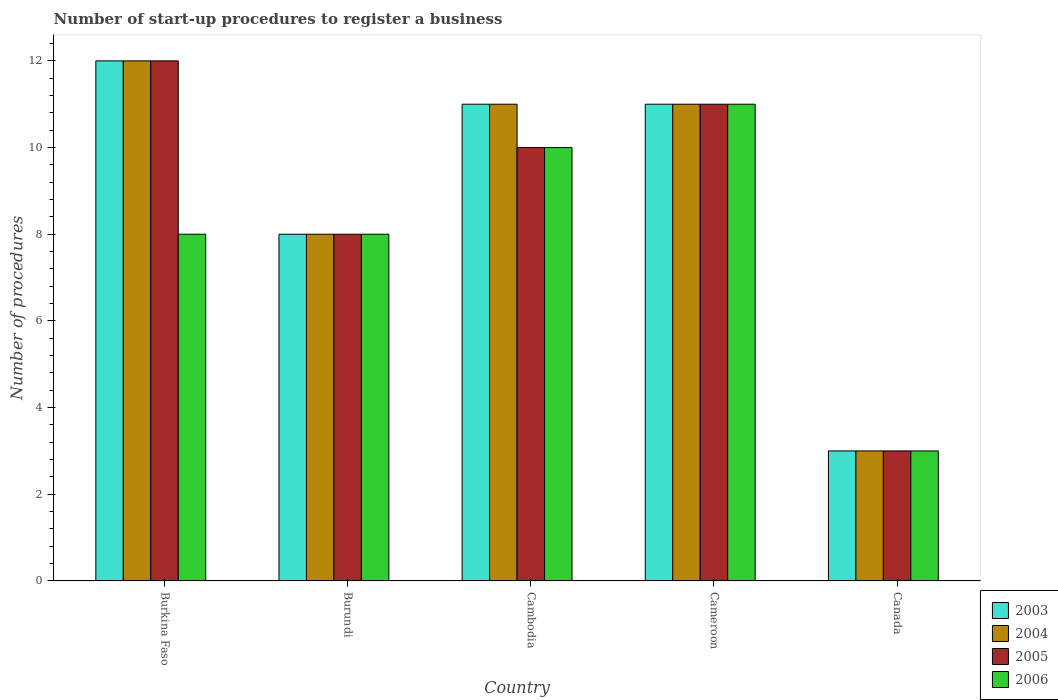How many different coloured bars are there?
Make the answer very short. 4. Are the number of bars per tick equal to the number of legend labels?
Ensure brevity in your answer.  Yes. How many bars are there on the 2nd tick from the left?
Your answer should be compact. 4. How many bars are there on the 4th tick from the right?
Your response must be concise. 4. What is the label of the 5th group of bars from the left?
Your response must be concise. Canada. In how many cases, is the number of bars for a given country not equal to the number of legend labels?
Make the answer very short. 0. What is the number of procedures required to register a business in 2003 in Burkina Faso?
Your answer should be very brief. 12. In which country was the number of procedures required to register a business in 2005 maximum?
Your answer should be very brief. Burkina Faso. What is the total number of procedures required to register a business in 2003 in the graph?
Keep it short and to the point. 45. What is the difference between the number of procedures required to register a business in 2006 in Burundi and that in Canada?
Offer a terse response. 5. What is the difference between the number of procedures required to register a business in 2003 in Burundi and the number of procedures required to register a business in 2006 in Canada?
Provide a succinct answer. 5. What is the average number of procedures required to register a business in 2005 per country?
Ensure brevity in your answer.  8.8. In how many countries, is the number of procedures required to register a business in 2003 greater than 9.6?
Keep it short and to the point. 3. What is the ratio of the number of procedures required to register a business in 2005 in Burkina Faso to that in Cambodia?
Provide a short and direct response. 1.2. In how many countries, is the number of procedures required to register a business in 2006 greater than the average number of procedures required to register a business in 2006 taken over all countries?
Ensure brevity in your answer.  2. Is the sum of the number of procedures required to register a business in 2003 in Cambodia and Cameroon greater than the maximum number of procedures required to register a business in 2006 across all countries?
Offer a terse response. Yes. What does the 1st bar from the left in Burkina Faso represents?
Keep it short and to the point. 2003. What does the 4th bar from the right in Burundi represents?
Offer a terse response. 2003. Is it the case that in every country, the sum of the number of procedures required to register a business in 2006 and number of procedures required to register a business in 2005 is greater than the number of procedures required to register a business in 2004?
Your answer should be very brief. Yes. Are all the bars in the graph horizontal?
Provide a succinct answer. No. Where does the legend appear in the graph?
Your answer should be compact. Bottom right. What is the title of the graph?
Give a very brief answer. Number of start-up procedures to register a business. What is the label or title of the Y-axis?
Your response must be concise. Number of procedures. What is the Number of procedures of 2005 in Burkina Faso?
Give a very brief answer. 12. What is the Number of procedures in 2006 in Burkina Faso?
Give a very brief answer. 8. What is the Number of procedures of 2005 in Burundi?
Offer a terse response. 8. What is the Number of procedures in 2006 in Burundi?
Provide a short and direct response. 8. What is the Number of procedures in 2003 in Cambodia?
Ensure brevity in your answer.  11. What is the Number of procedures of 2004 in Cambodia?
Offer a terse response. 11. What is the Number of procedures of 2005 in Cambodia?
Provide a short and direct response. 10. What is the Number of procedures in 2006 in Cambodia?
Provide a succinct answer. 10. What is the Number of procedures of 2003 in Cameroon?
Your response must be concise. 11. What is the Number of procedures of 2005 in Cameroon?
Ensure brevity in your answer.  11. What is the Number of procedures in 2003 in Canada?
Offer a terse response. 3. What is the Number of procedures of 2006 in Canada?
Offer a terse response. 3. Across all countries, what is the minimum Number of procedures of 2004?
Provide a short and direct response. 3. Across all countries, what is the minimum Number of procedures in 2005?
Offer a terse response. 3. What is the total Number of procedures of 2003 in the graph?
Keep it short and to the point. 45. What is the total Number of procedures in 2004 in the graph?
Give a very brief answer. 45. What is the total Number of procedures of 2005 in the graph?
Give a very brief answer. 44. What is the difference between the Number of procedures of 2003 in Burkina Faso and that in Burundi?
Ensure brevity in your answer.  4. What is the difference between the Number of procedures of 2004 in Burkina Faso and that in Burundi?
Provide a short and direct response. 4. What is the difference between the Number of procedures of 2005 in Burkina Faso and that in Burundi?
Your answer should be very brief. 4. What is the difference between the Number of procedures in 2006 in Burkina Faso and that in Burundi?
Make the answer very short. 0. What is the difference between the Number of procedures of 2003 in Burkina Faso and that in Cambodia?
Offer a very short reply. 1. What is the difference between the Number of procedures in 2006 in Burkina Faso and that in Cambodia?
Your response must be concise. -2. What is the difference between the Number of procedures in 2004 in Burkina Faso and that in Cameroon?
Make the answer very short. 1. What is the difference between the Number of procedures of 2005 in Burkina Faso and that in Cameroon?
Provide a succinct answer. 1. What is the difference between the Number of procedures of 2004 in Burkina Faso and that in Canada?
Offer a terse response. 9. What is the difference between the Number of procedures of 2005 in Burkina Faso and that in Canada?
Offer a terse response. 9. What is the difference between the Number of procedures of 2006 in Burkina Faso and that in Canada?
Provide a succinct answer. 5. What is the difference between the Number of procedures of 2005 in Burundi and that in Cambodia?
Your response must be concise. -2. What is the difference between the Number of procedures in 2003 in Burundi and that in Cameroon?
Offer a terse response. -3. What is the difference between the Number of procedures in 2004 in Burundi and that in Cameroon?
Make the answer very short. -3. What is the difference between the Number of procedures of 2003 in Burundi and that in Canada?
Your response must be concise. 5. What is the difference between the Number of procedures of 2005 in Burundi and that in Canada?
Provide a short and direct response. 5. What is the difference between the Number of procedures of 2005 in Cambodia and that in Cameroon?
Provide a succinct answer. -1. What is the difference between the Number of procedures of 2005 in Cambodia and that in Canada?
Your answer should be compact. 7. What is the difference between the Number of procedures in 2006 in Cambodia and that in Canada?
Your response must be concise. 7. What is the difference between the Number of procedures in 2003 in Cameroon and that in Canada?
Offer a very short reply. 8. What is the difference between the Number of procedures in 2004 in Cameroon and that in Canada?
Provide a short and direct response. 8. What is the difference between the Number of procedures in 2005 in Cameroon and that in Canada?
Your answer should be compact. 8. What is the difference between the Number of procedures of 2003 in Burkina Faso and the Number of procedures of 2004 in Burundi?
Your answer should be compact. 4. What is the difference between the Number of procedures of 2004 in Burkina Faso and the Number of procedures of 2006 in Burundi?
Keep it short and to the point. 4. What is the difference between the Number of procedures of 2004 in Burkina Faso and the Number of procedures of 2006 in Cambodia?
Offer a terse response. 2. What is the difference between the Number of procedures of 2003 in Burkina Faso and the Number of procedures of 2005 in Cameroon?
Your answer should be compact. 1. What is the difference between the Number of procedures in 2004 in Burkina Faso and the Number of procedures in 2005 in Cameroon?
Keep it short and to the point. 1. What is the difference between the Number of procedures of 2003 in Burkina Faso and the Number of procedures of 2005 in Canada?
Make the answer very short. 9. What is the difference between the Number of procedures of 2004 in Burkina Faso and the Number of procedures of 2005 in Canada?
Give a very brief answer. 9. What is the difference between the Number of procedures of 2004 in Burkina Faso and the Number of procedures of 2006 in Canada?
Offer a terse response. 9. What is the difference between the Number of procedures of 2003 in Burundi and the Number of procedures of 2004 in Cambodia?
Provide a succinct answer. -3. What is the difference between the Number of procedures of 2003 in Burundi and the Number of procedures of 2006 in Cambodia?
Give a very brief answer. -2. What is the difference between the Number of procedures in 2004 in Burundi and the Number of procedures in 2005 in Canada?
Your answer should be compact. 5. What is the difference between the Number of procedures of 2004 in Burundi and the Number of procedures of 2006 in Canada?
Give a very brief answer. 5. What is the difference between the Number of procedures in 2003 in Cambodia and the Number of procedures in 2004 in Cameroon?
Your answer should be very brief. 0. What is the difference between the Number of procedures of 2003 in Cambodia and the Number of procedures of 2005 in Cameroon?
Provide a succinct answer. 0. What is the difference between the Number of procedures of 2003 in Cambodia and the Number of procedures of 2006 in Cameroon?
Your answer should be very brief. 0. What is the difference between the Number of procedures in 2003 in Cambodia and the Number of procedures in 2005 in Canada?
Offer a terse response. 8. What is the difference between the Number of procedures in 2003 in Cambodia and the Number of procedures in 2006 in Canada?
Provide a short and direct response. 8. What is the difference between the Number of procedures in 2003 in Cameroon and the Number of procedures in 2004 in Canada?
Your answer should be compact. 8. What is the difference between the Number of procedures of 2003 in Cameroon and the Number of procedures of 2005 in Canada?
Make the answer very short. 8. What is the difference between the Number of procedures of 2003 in Cameroon and the Number of procedures of 2006 in Canada?
Give a very brief answer. 8. What is the difference between the Number of procedures in 2004 in Cameroon and the Number of procedures in 2005 in Canada?
Offer a very short reply. 8. What is the average Number of procedures of 2004 per country?
Your response must be concise. 9. What is the difference between the Number of procedures in 2003 and Number of procedures in 2005 in Burkina Faso?
Your response must be concise. 0. What is the difference between the Number of procedures of 2003 and Number of procedures of 2006 in Burkina Faso?
Your answer should be very brief. 4. What is the difference between the Number of procedures of 2004 and Number of procedures of 2005 in Burkina Faso?
Offer a very short reply. 0. What is the difference between the Number of procedures in 2003 and Number of procedures in 2004 in Burundi?
Provide a short and direct response. 0. What is the difference between the Number of procedures of 2003 and Number of procedures of 2005 in Burundi?
Ensure brevity in your answer.  0. What is the difference between the Number of procedures in 2003 and Number of procedures in 2006 in Burundi?
Give a very brief answer. 0. What is the difference between the Number of procedures in 2004 and Number of procedures in 2005 in Burundi?
Give a very brief answer. 0. What is the difference between the Number of procedures of 2003 and Number of procedures of 2006 in Cambodia?
Offer a terse response. 1. What is the difference between the Number of procedures of 2003 and Number of procedures of 2005 in Cameroon?
Your response must be concise. 0. What is the difference between the Number of procedures of 2004 and Number of procedures of 2006 in Cameroon?
Give a very brief answer. 0. What is the difference between the Number of procedures in 2003 and Number of procedures in 2006 in Canada?
Offer a very short reply. 0. What is the difference between the Number of procedures in 2004 and Number of procedures in 2005 in Canada?
Ensure brevity in your answer.  0. What is the difference between the Number of procedures in 2004 and Number of procedures in 2006 in Canada?
Offer a terse response. 0. What is the difference between the Number of procedures of 2005 and Number of procedures of 2006 in Canada?
Your answer should be very brief. 0. What is the ratio of the Number of procedures in 2003 in Burkina Faso to that in Burundi?
Keep it short and to the point. 1.5. What is the ratio of the Number of procedures in 2005 in Burkina Faso to that in Burundi?
Ensure brevity in your answer.  1.5. What is the ratio of the Number of procedures in 2006 in Burkina Faso to that in Burundi?
Provide a succinct answer. 1. What is the ratio of the Number of procedures in 2003 in Burkina Faso to that in Cambodia?
Keep it short and to the point. 1.09. What is the ratio of the Number of procedures of 2004 in Burkina Faso to that in Cambodia?
Give a very brief answer. 1.09. What is the ratio of the Number of procedures of 2006 in Burkina Faso to that in Cambodia?
Your answer should be compact. 0.8. What is the ratio of the Number of procedures in 2004 in Burkina Faso to that in Cameroon?
Make the answer very short. 1.09. What is the ratio of the Number of procedures of 2005 in Burkina Faso to that in Cameroon?
Keep it short and to the point. 1.09. What is the ratio of the Number of procedures in 2006 in Burkina Faso to that in Cameroon?
Your answer should be compact. 0.73. What is the ratio of the Number of procedures of 2005 in Burkina Faso to that in Canada?
Provide a short and direct response. 4. What is the ratio of the Number of procedures of 2006 in Burkina Faso to that in Canada?
Provide a succinct answer. 2.67. What is the ratio of the Number of procedures of 2003 in Burundi to that in Cambodia?
Ensure brevity in your answer.  0.73. What is the ratio of the Number of procedures of 2004 in Burundi to that in Cambodia?
Provide a succinct answer. 0.73. What is the ratio of the Number of procedures in 2005 in Burundi to that in Cambodia?
Your answer should be very brief. 0.8. What is the ratio of the Number of procedures in 2003 in Burundi to that in Cameroon?
Keep it short and to the point. 0.73. What is the ratio of the Number of procedures in 2004 in Burundi to that in Cameroon?
Offer a very short reply. 0.73. What is the ratio of the Number of procedures in 2005 in Burundi to that in Cameroon?
Keep it short and to the point. 0.73. What is the ratio of the Number of procedures of 2006 in Burundi to that in Cameroon?
Keep it short and to the point. 0.73. What is the ratio of the Number of procedures of 2003 in Burundi to that in Canada?
Provide a short and direct response. 2.67. What is the ratio of the Number of procedures of 2004 in Burundi to that in Canada?
Make the answer very short. 2.67. What is the ratio of the Number of procedures in 2005 in Burundi to that in Canada?
Provide a succinct answer. 2.67. What is the ratio of the Number of procedures of 2006 in Burundi to that in Canada?
Your answer should be very brief. 2.67. What is the ratio of the Number of procedures in 2003 in Cambodia to that in Cameroon?
Ensure brevity in your answer.  1. What is the ratio of the Number of procedures of 2004 in Cambodia to that in Cameroon?
Offer a terse response. 1. What is the ratio of the Number of procedures of 2006 in Cambodia to that in Cameroon?
Your answer should be compact. 0.91. What is the ratio of the Number of procedures in 2003 in Cambodia to that in Canada?
Make the answer very short. 3.67. What is the ratio of the Number of procedures of 2004 in Cambodia to that in Canada?
Keep it short and to the point. 3.67. What is the ratio of the Number of procedures in 2006 in Cambodia to that in Canada?
Your answer should be very brief. 3.33. What is the ratio of the Number of procedures in 2003 in Cameroon to that in Canada?
Ensure brevity in your answer.  3.67. What is the ratio of the Number of procedures of 2004 in Cameroon to that in Canada?
Give a very brief answer. 3.67. What is the ratio of the Number of procedures of 2005 in Cameroon to that in Canada?
Your response must be concise. 3.67. What is the ratio of the Number of procedures of 2006 in Cameroon to that in Canada?
Give a very brief answer. 3.67. What is the difference between the highest and the second highest Number of procedures of 2003?
Provide a succinct answer. 1. What is the difference between the highest and the second highest Number of procedures of 2004?
Ensure brevity in your answer.  1. What is the difference between the highest and the lowest Number of procedures in 2004?
Your response must be concise. 9. What is the difference between the highest and the lowest Number of procedures in 2005?
Your answer should be compact. 9. What is the difference between the highest and the lowest Number of procedures in 2006?
Provide a short and direct response. 8. 